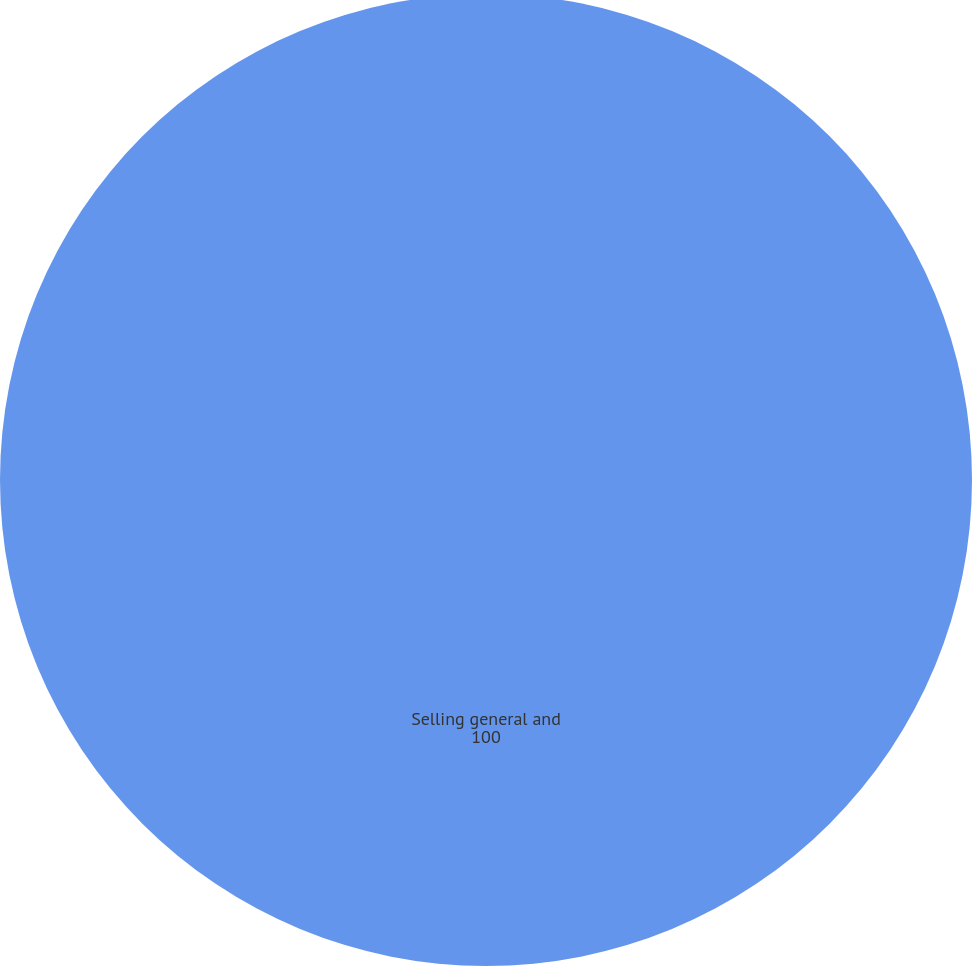Convert chart. <chart><loc_0><loc_0><loc_500><loc_500><pie_chart><fcel>Selling general and<nl><fcel>100.0%<nl></chart> 